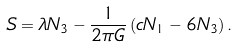Convert formula to latex. <formula><loc_0><loc_0><loc_500><loc_500>S = \lambda N _ { 3 } - \frac { 1 } { 2 \pi G } \left ( c N _ { 1 } - 6 N _ { 3 } \right ) .</formula> 